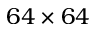Convert formula to latex. <formula><loc_0><loc_0><loc_500><loc_500>6 4 \times 6 4</formula> 